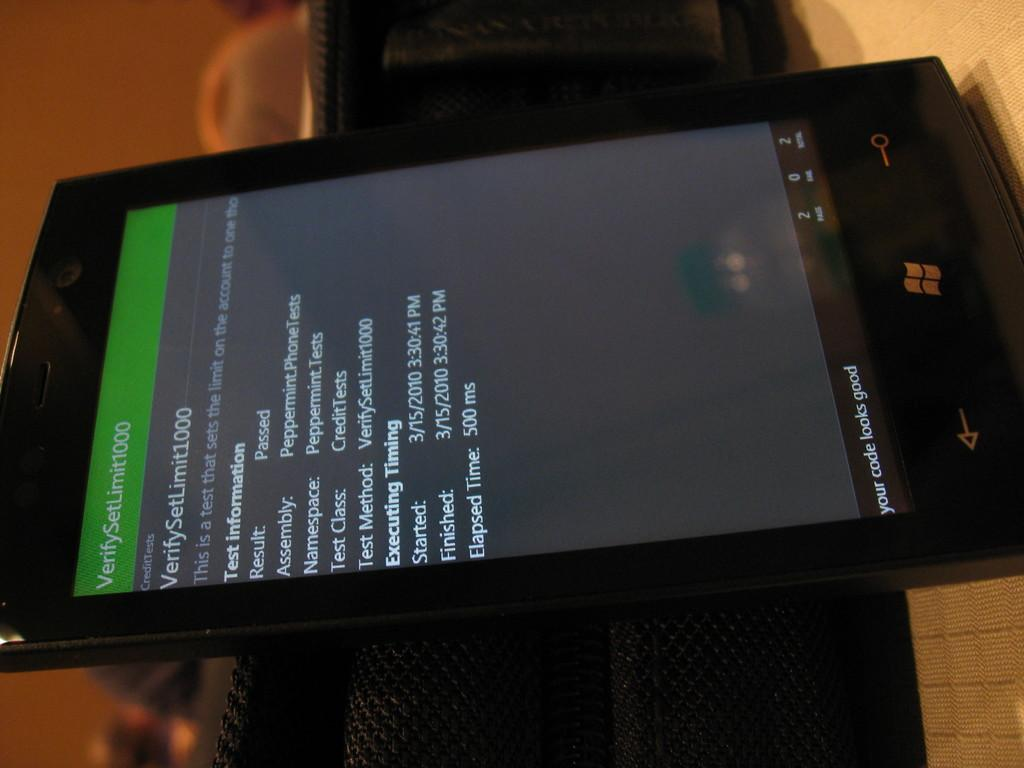<image>
Relay a brief, clear account of the picture shown. A cell phone on its side with the words Credit Tests visible 